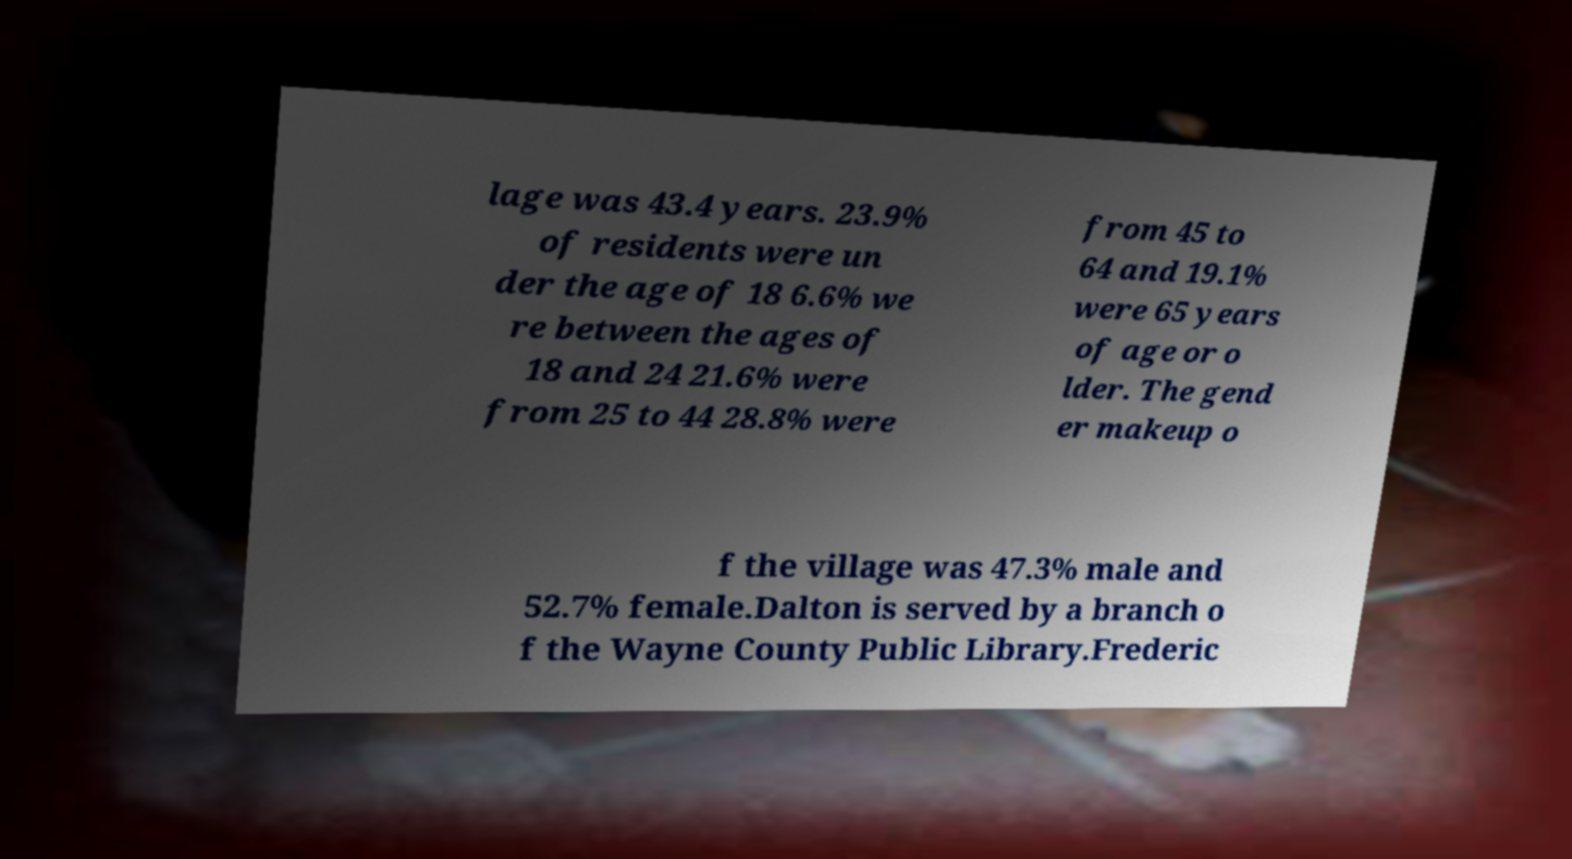Please read and relay the text visible in this image. What does it say? lage was 43.4 years. 23.9% of residents were un der the age of 18 6.6% we re between the ages of 18 and 24 21.6% were from 25 to 44 28.8% were from 45 to 64 and 19.1% were 65 years of age or o lder. The gend er makeup o f the village was 47.3% male and 52.7% female.Dalton is served by a branch o f the Wayne County Public Library.Frederic 